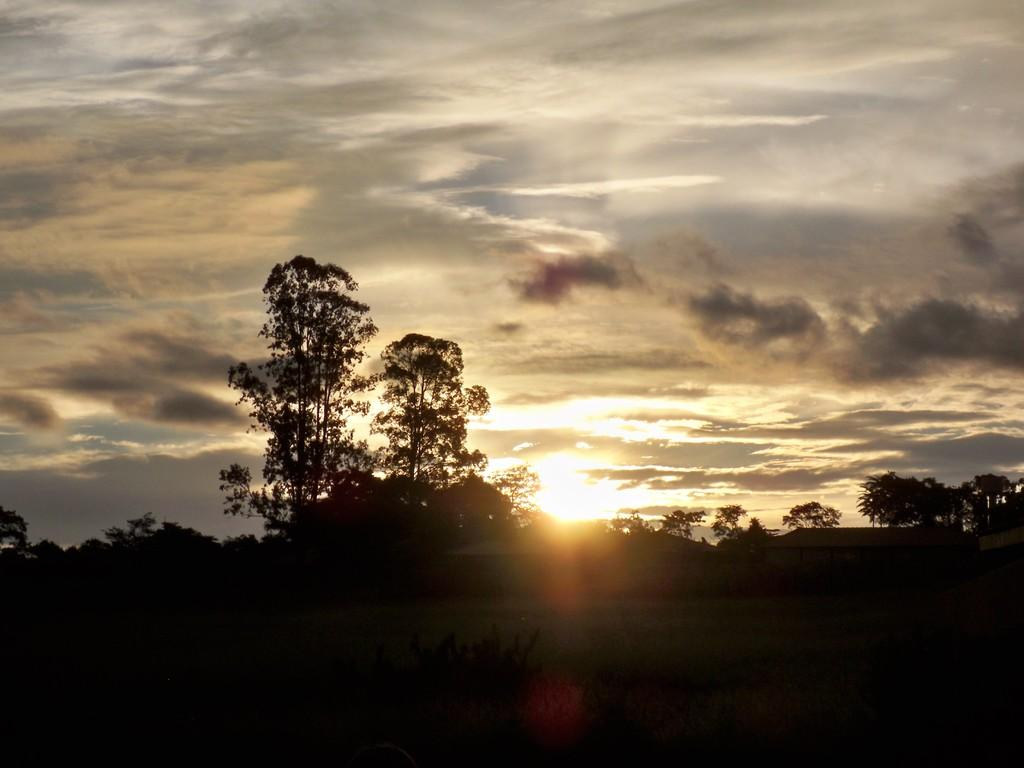What type of vegetation is present on the ground in the image? There are plants and trees on the ground in the image. What can be seen in the sky in the image? The sky is visible in the image, and the sun and clouds are present. Can you describe the sun's position in the sky? The sun is observable in the sky, but its position cannot be determined from the image alone. What type of advice does the lawyer give to the wing in the image? There is no lawyer or wing present in the image; it features plants, trees, and a sky with the sun and clouds. 